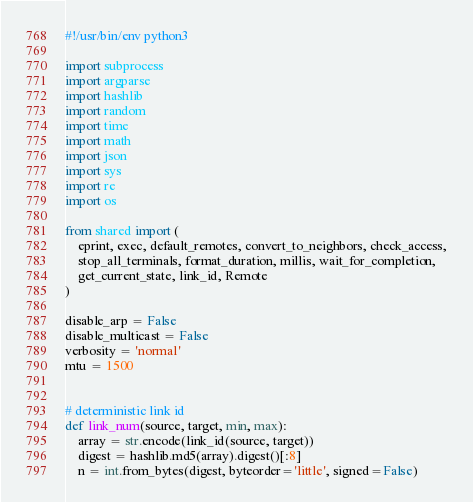Convert code to text. <code><loc_0><loc_0><loc_500><loc_500><_Python_>#!/usr/bin/env python3

import subprocess
import argparse
import hashlib
import random
import time
import math
import json
import sys
import re
import os

from shared import (
    eprint, exec, default_remotes, convert_to_neighbors, check_access,
    stop_all_terminals, format_duration, millis, wait_for_completion,
    get_current_state, link_id, Remote
)

disable_arp = False
disable_multicast = False
verbosity = 'normal'
mtu = 1500


# deterministic link id
def link_num(source, target, min, max):
    array = str.encode(link_id(source, target))
    digest = hashlib.md5(array).digest()[:8]
    n = int.from_bytes(digest, byteorder='little', signed=False)</code> 